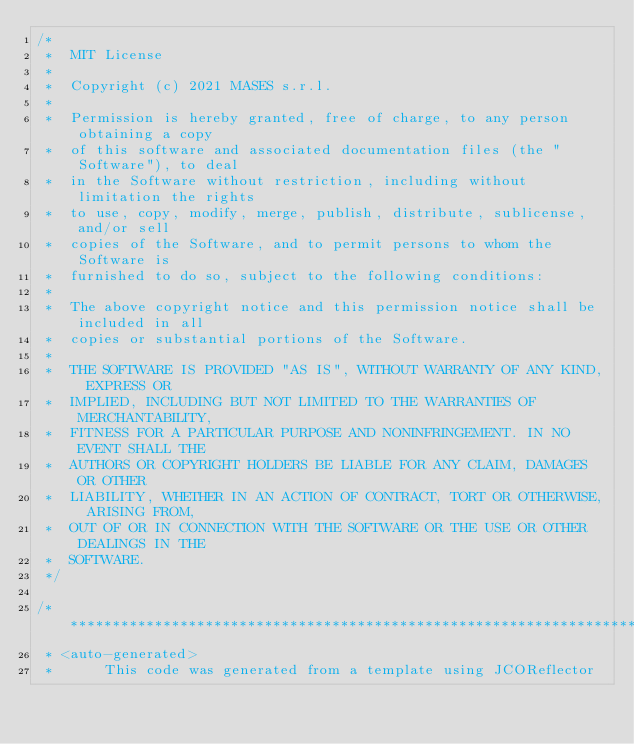<code> <loc_0><loc_0><loc_500><loc_500><_Java_>/*
 *  MIT License
 *
 *  Copyright (c) 2021 MASES s.r.l.
 *
 *  Permission is hereby granted, free of charge, to any person obtaining a copy
 *  of this software and associated documentation files (the "Software"), to deal
 *  in the Software without restriction, including without limitation the rights
 *  to use, copy, modify, merge, publish, distribute, sublicense, and/or sell
 *  copies of the Software, and to permit persons to whom the Software is
 *  furnished to do so, subject to the following conditions:
 *
 *  The above copyright notice and this permission notice shall be included in all
 *  copies or substantial portions of the Software.
 *
 *  THE SOFTWARE IS PROVIDED "AS IS", WITHOUT WARRANTY OF ANY KIND, EXPRESS OR
 *  IMPLIED, INCLUDING BUT NOT LIMITED TO THE WARRANTIES OF MERCHANTABILITY,
 *  FITNESS FOR A PARTICULAR PURPOSE AND NONINFRINGEMENT. IN NO EVENT SHALL THE
 *  AUTHORS OR COPYRIGHT HOLDERS BE LIABLE FOR ANY CLAIM, DAMAGES OR OTHER
 *  LIABILITY, WHETHER IN AN ACTION OF CONTRACT, TORT OR OTHERWISE, ARISING FROM,
 *  OUT OF OR IN CONNECTION WITH THE SOFTWARE OR THE USE OR OTHER DEALINGS IN THE
 *  SOFTWARE.
 */

/**************************************************************************************
 * <auto-generated>
 *      This code was generated from a template using JCOReflector</code> 